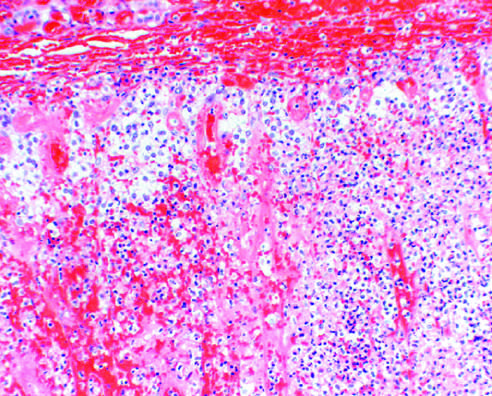did haphazard crypt organization result in acute adrenal insufficiency?
Answer the question using a single word or phrase. No 